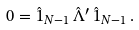<formula> <loc_0><loc_0><loc_500><loc_500>0 = { \hat { 1 } } _ { N - 1 } \, { \hat { \Lambda } } ^ { \prime } \, { \hat { 1 } } _ { N - 1 } \, .</formula> 